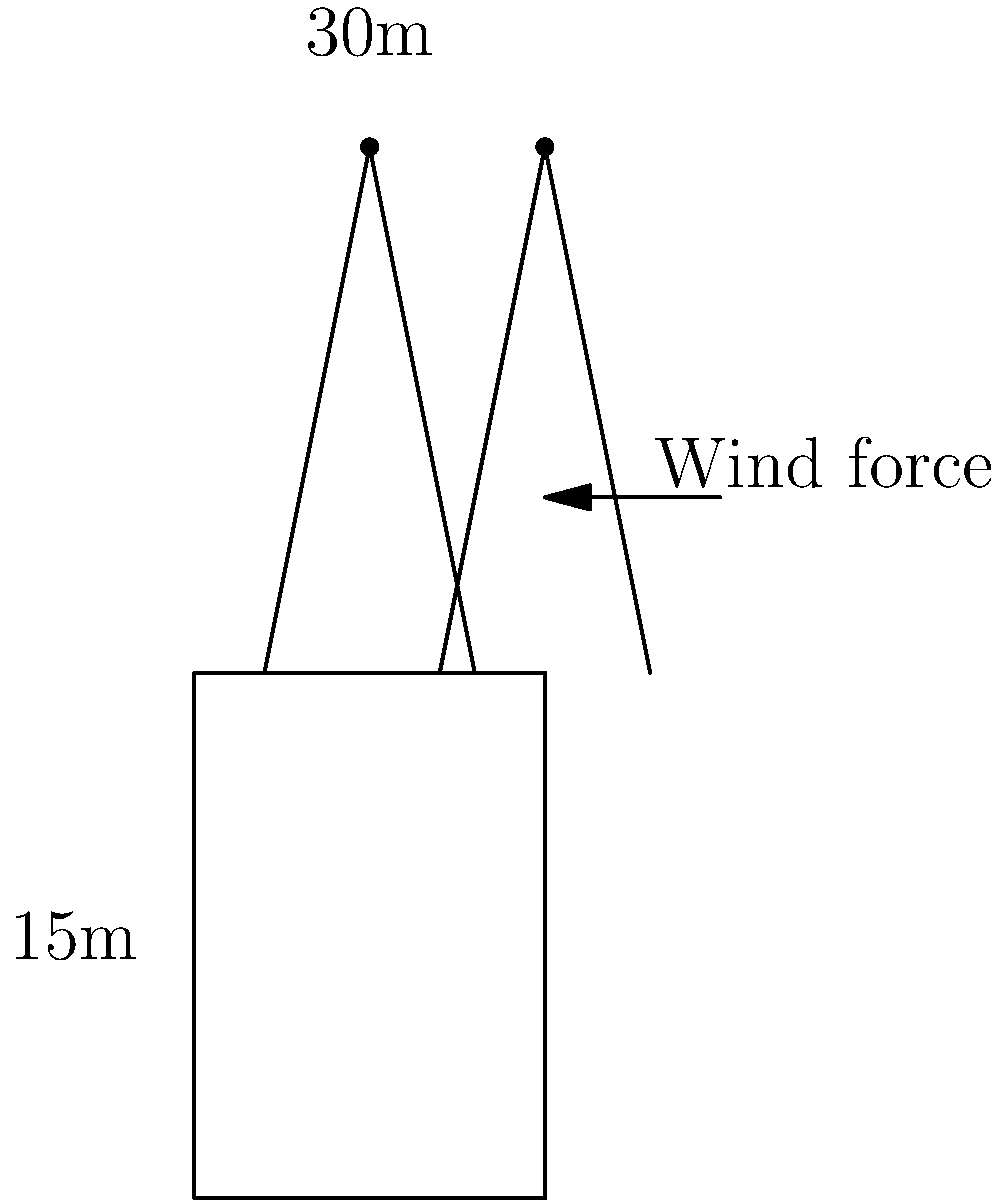The Zagreb Cathedral's twin spires, each 30m tall, are subjected to strong winds. Using the simplified diagram, if the wind exerts a horizontal force of 50 kN on each spire, what is the maximum bending moment (in kNm) at the base of one spire? Assume the spire behaves as a cantilever beam. To solve this problem, we'll follow these steps:

1. Identify the structural model:
   Each spire can be modeled as a cantilever beam fixed at the base.

2. Understand the loading:
   The wind force acts as a point load at the top of the spire.

3. Recall the formula for maximum bending moment in a cantilever:
   $$M_{max} = F \cdot L$$
   Where:
   $M_{max}$ = maximum bending moment
   $F$ = applied force
   $L$ = length of the cantilever

4. Input the given values:
   $F = 50 \text{ kN}$
   $L = 30 \text{ m}$

5. Calculate the maximum bending moment:
   $$M_{max} = 50 \text{ kN} \cdot 30 \text{ m} = 1500 \text{ kNm}$$

Therefore, the maximum bending moment at the base of one spire is 1500 kNm.
Answer: 1500 kNm 